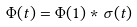<formula> <loc_0><loc_0><loc_500><loc_500>\Phi ( t ) = \Phi ( 1 ) * \sigma ( t )</formula> 